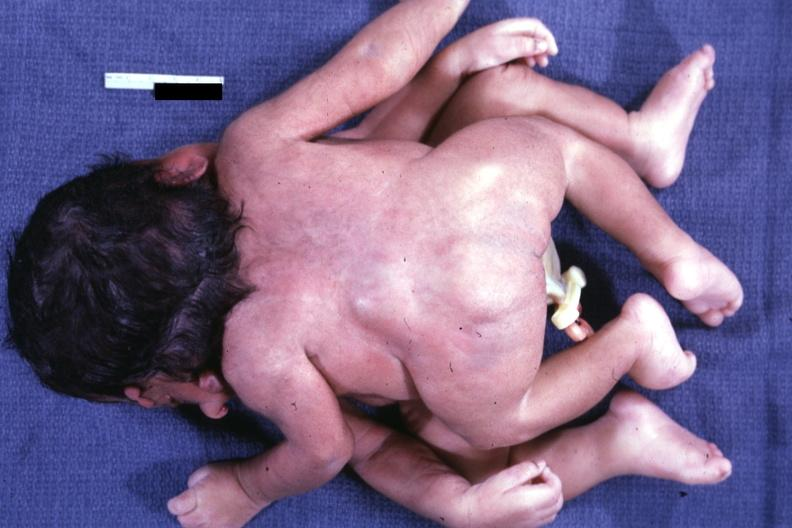what is twins joined?
Answer the question using a single word or phrase. At head facing each other 